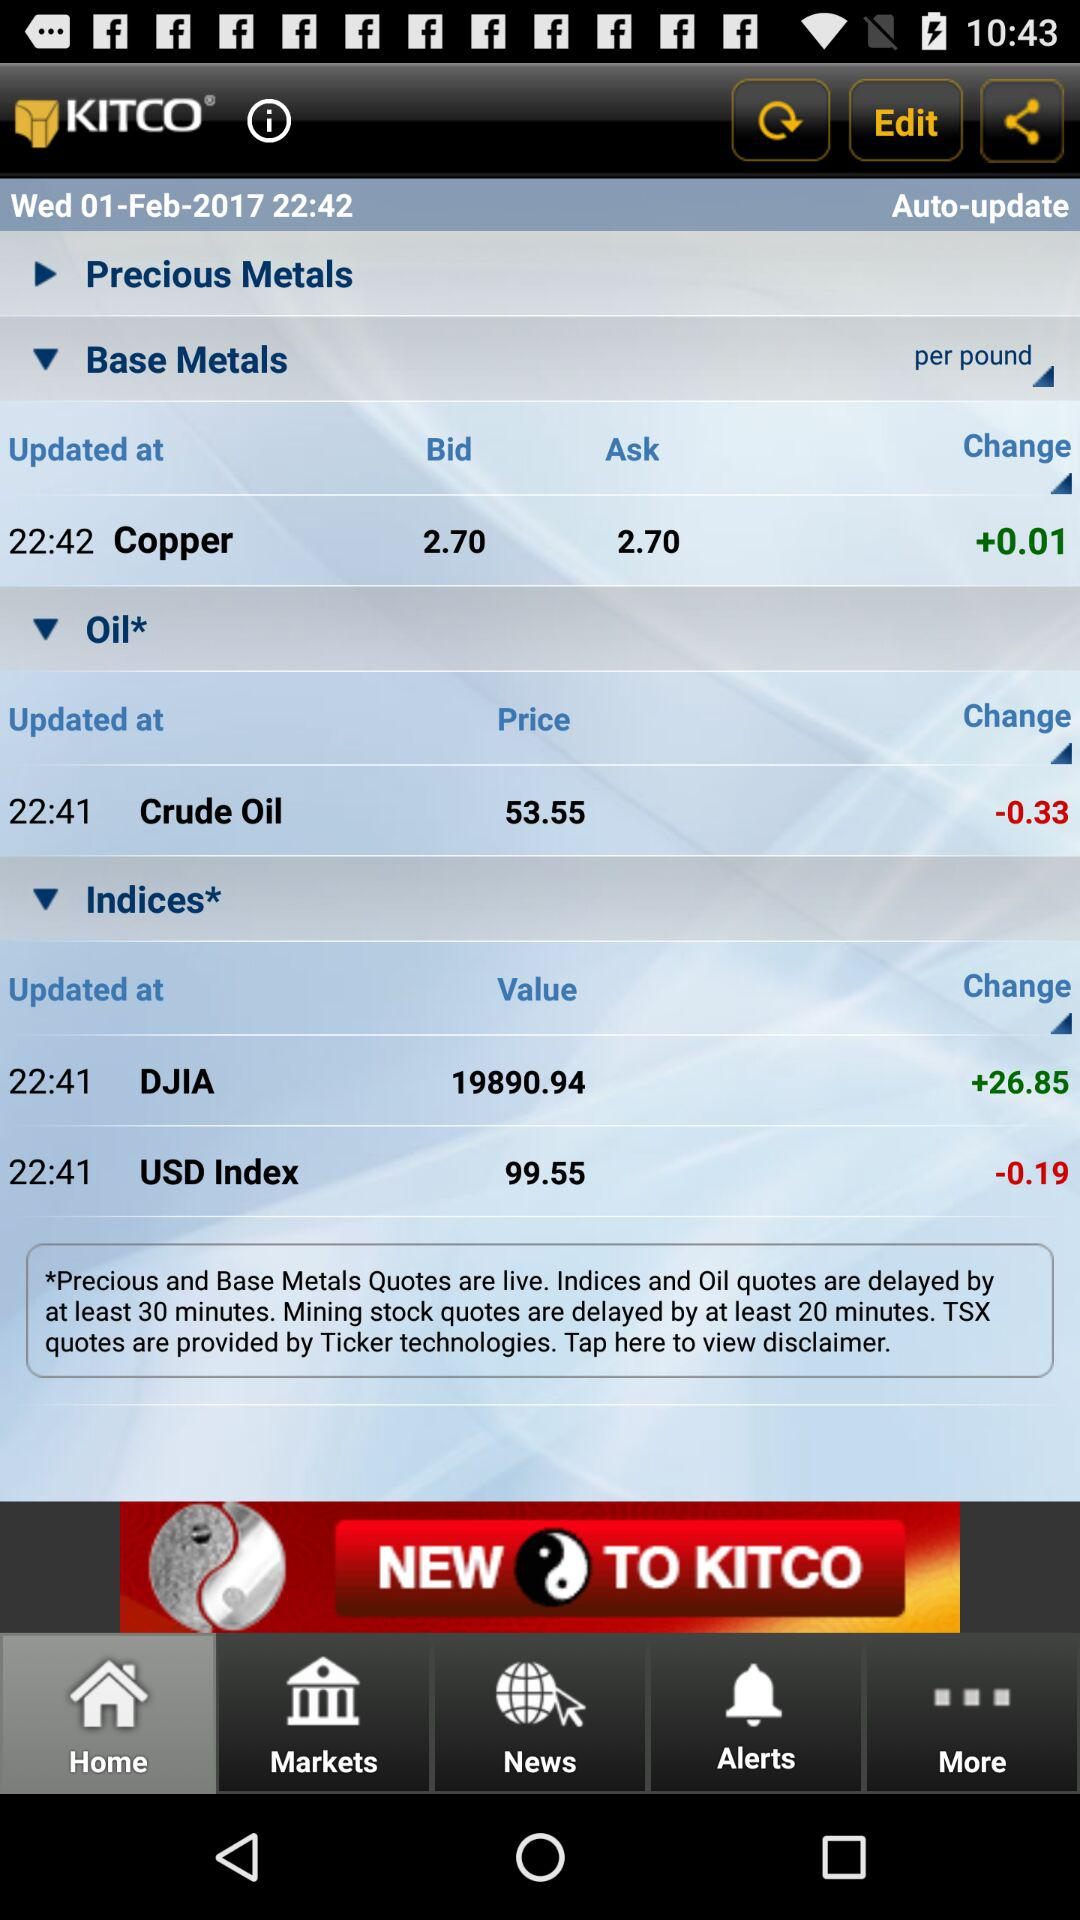When was the price of crude oil updated? The price of crude oil was updated at 22:41. 